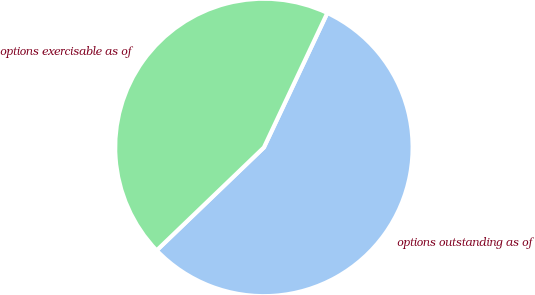Convert chart to OTSL. <chart><loc_0><loc_0><loc_500><loc_500><pie_chart><fcel>options outstanding as of<fcel>options exercisable as of<nl><fcel>55.81%<fcel>44.19%<nl></chart> 